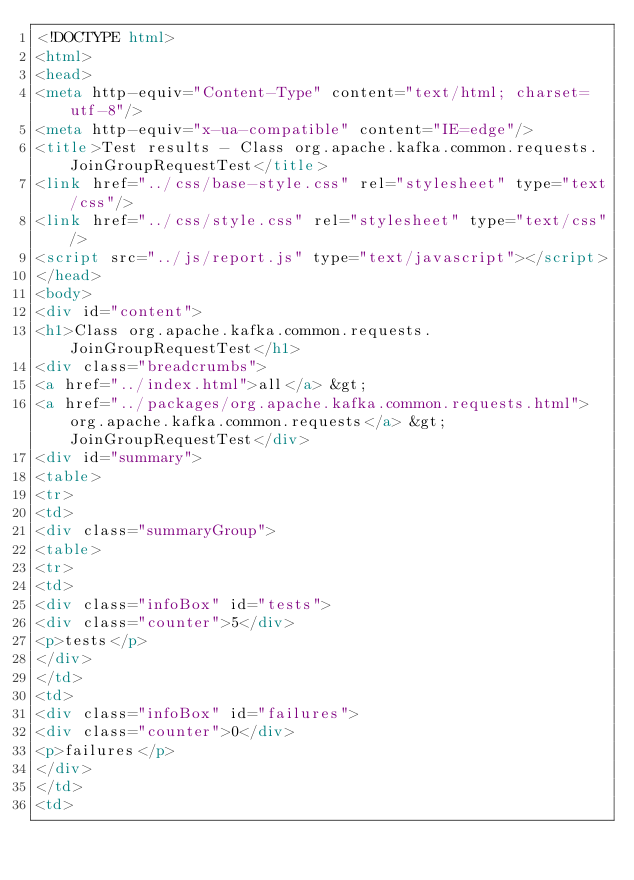Convert code to text. <code><loc_0><loc_0><loc_500><loc_500><_HTML_><!DOCTYPE html>
<html>
<head>
<meta http-equiv="Content-Type" content="text/html; charset=utf-8"/>
<meta http-equiv="x-ua-compatible" content="IE=edge"/>
<title>Test results - Class org.apache.kafka.common.requests.JoinGroupRequestTest</title>
<link href="../css/base-style.css" rel="stylesheet" type="text/css"/>
<link href="../css/style.css" rel="stylesheet" type="text/css"/>
<script src="../js/report.js" type="text/javascript"></script>
</head>
<body>
<div id="content">
<h1>Class org.apache.kafka.common.requests.JoinGroupRequestTest</h1>
<div class="breadcrumbs">
<a href="../index.html">all</a> &gt; 
<a href="../packages/org.apache.kafka.common.requests.html">org.apache.kafka.common.requests</a> &gt; JoinGroupRequestTest</div>
<div id="summary">
<table>
<tr>
<td>
<div class="summaryGroup">
<table>
<tr>
<td>
<div class="infoBox" id="tests">
<div class="counter">5</div>
<p>tests</p>
</div>
</td>
<td>
<div class="infoBox" id="failures">
<div class="counter">0</div>
<p>failures</p>
</div>
</td>
<td></code> 